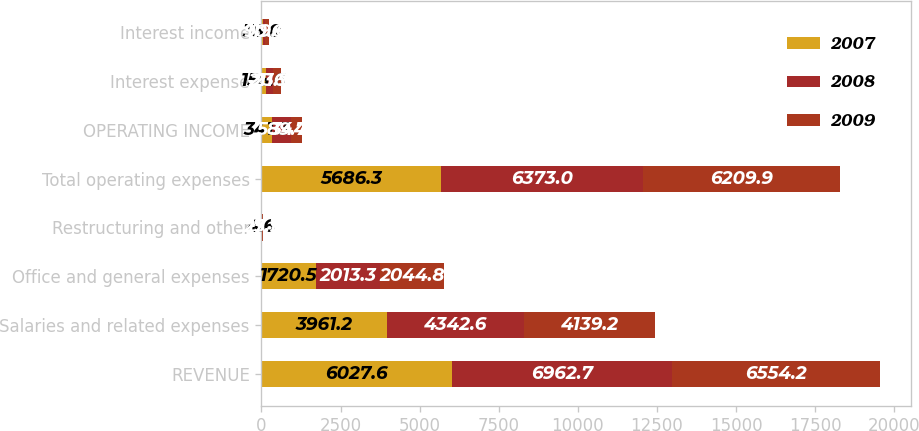<chart> <loc_0><loc_0><loc_500><loc_500><stacked_bar_chart><ecel><fcel>REVENUE<fcel>Salaries and related expenses<fcel>Office and general expenses<fcel>Restructuring and other<fcel>Total operating expenses<fcel>OPERATING INCOME<fcel>Interest expense<fcel>Interest income<nl><fcel>2007<fcel>6027.6<fcel>3961.2<fcel>1720.5<fcel>4.6<fcel>5686.3<fcel>341.3<fcel>155.6<fcel>35<nl><fcel>2008<fcel>6962.7<fcel>4342.6<fcel>2013.3<fcel>17.1<fcel>6373<fcel>589.7<fcel>211.9<fcel>90.6<nl><fcel>2009<fcel>6554.2<fcel>4139.2<fcel>2044.8<fcel>25.9<fcel>6209.9<fcel>344.3<fcel>236.7<fcel>119.6<nl></chart> 